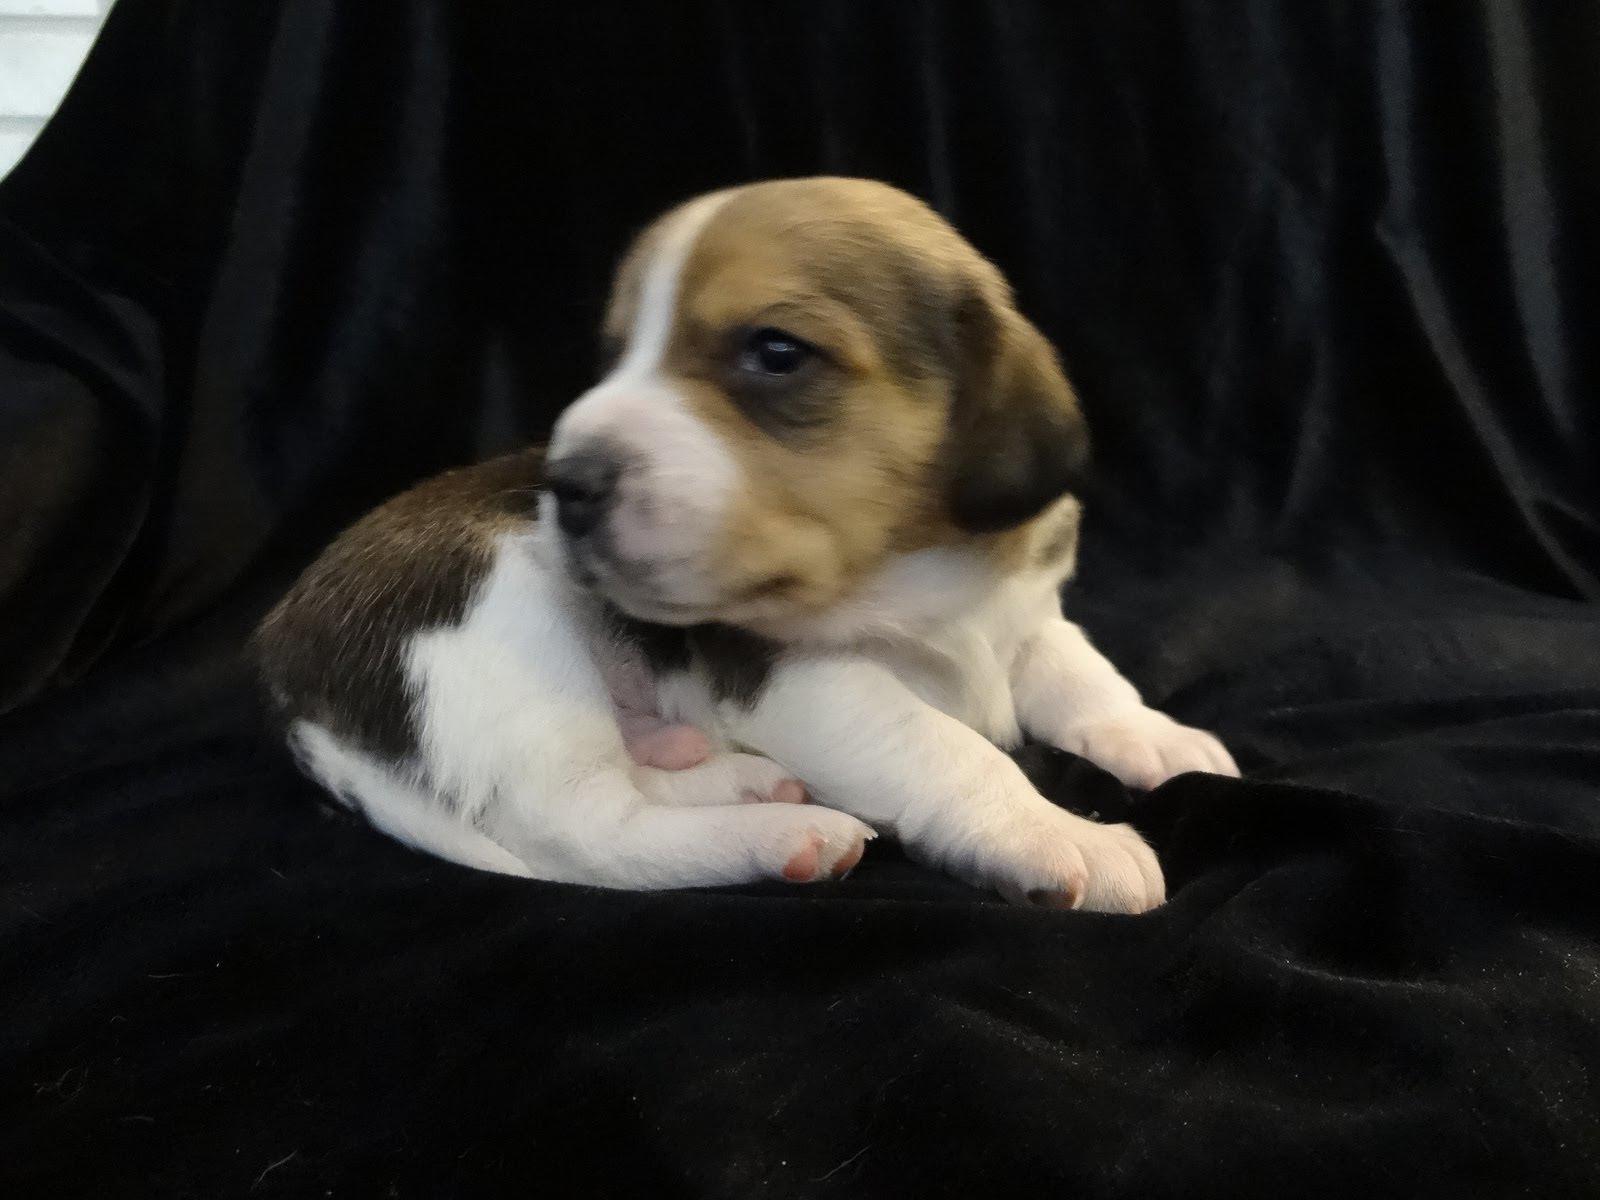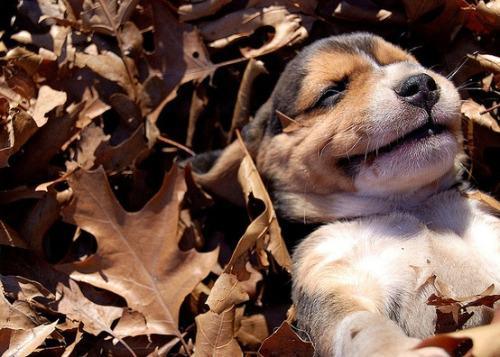The first image is the image on the left, the second image is the image on the right. Evaluate the accuracy of this statement regarding the images: "In one of the images, there are more than three puppies.". Is it true? Answer yes or no. No. The first image is the image on the left, the second image is the image on the right. Examine the images to the left and right. Is the description "There are at most three dogs." accurate? Answer yes or no. Yes. 